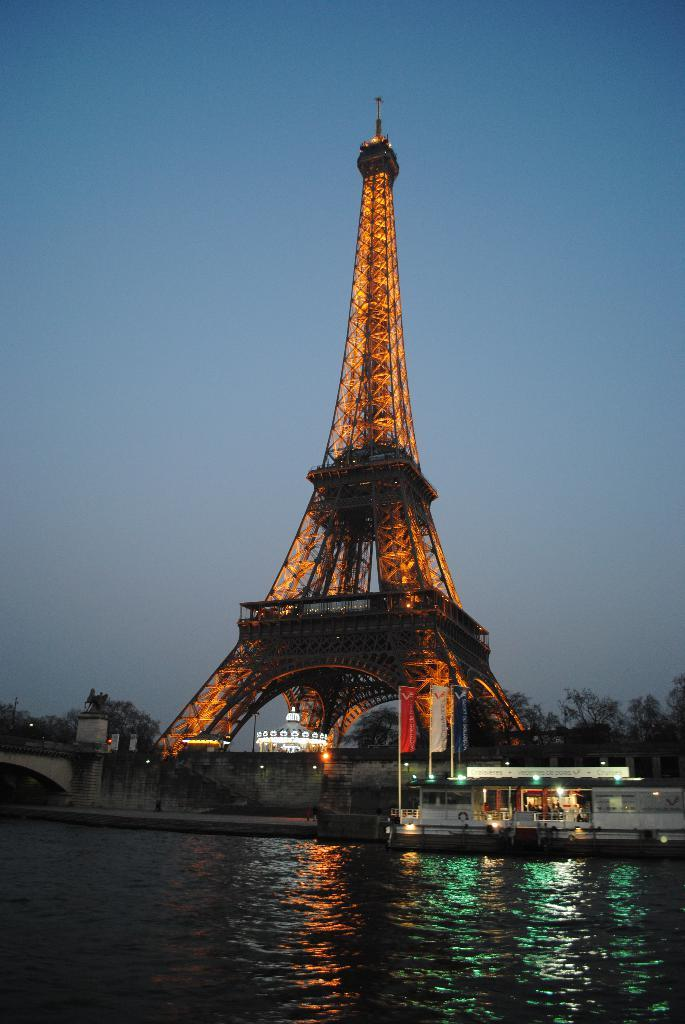What is the main feature of the image? There is water in the image. What famous landmark can be seen in the background? The Eiffel Tower is visible in the background. What other objects or features are present in the image? There are flags, trees, and a bridge on the left side of the image. What can be seen at the top of the image? The sky is visible at the top of the image. How many pigs are swimming in the water in the image? There are no pigs present in the image. What act are the trees performing in the image? Trees do not perform acts; they are stationary objects in the image. 